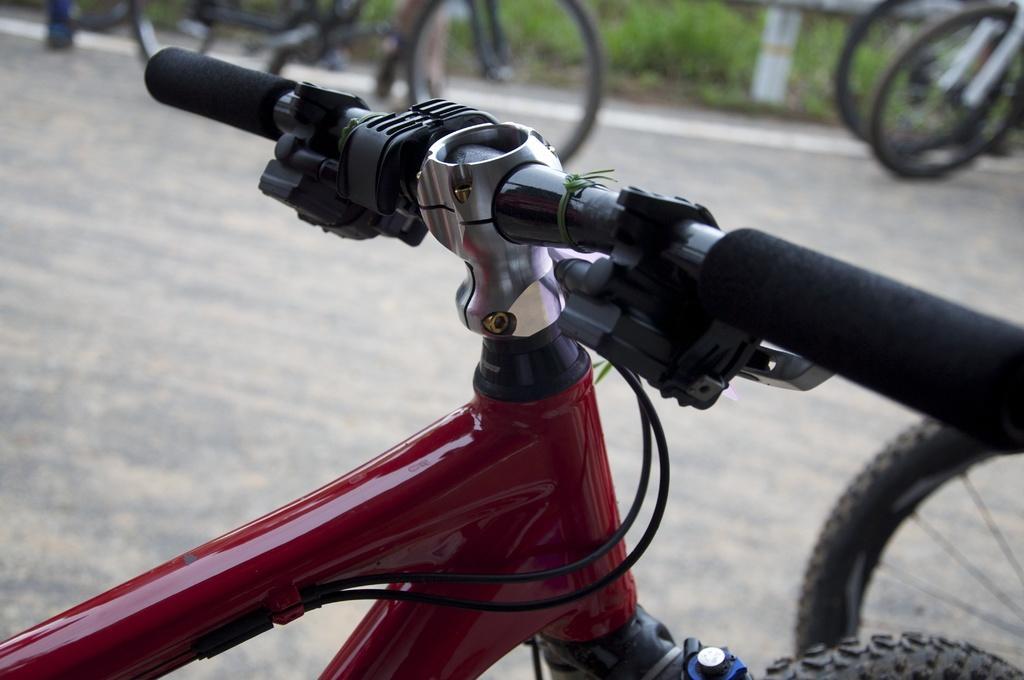How would you summarize this image in a sentence or two? In this image I can see few bicycles. In front the bicycle is in red and black color. In the background I can see few plants in green color. 